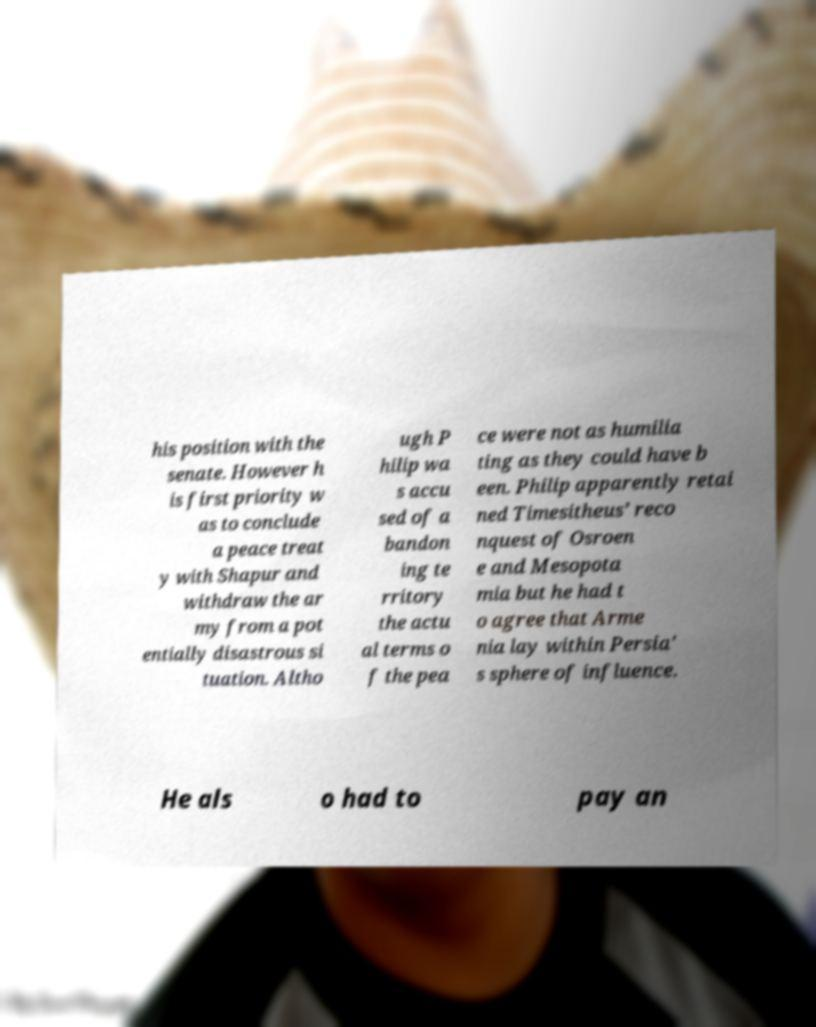Can you accurately transcribe the text from the provided image for me? his position with the senate. However h is first priority w as to conclude a peace treat y with Shapur and withdraw the ar my from a pot entially disastrous si tuation. Altho ugh P hilip wa s accu sed of a bandon ing te rritory the actu al terms o f the pea ce were not as humilia ting as they could have b een. Philip apparently retai ned Timesitheus’ reco nquest of Osroen e and Mesopota mia but he had t o agree that Arme nia lay within Persia' s sphere of influence. He als o had to pay an 